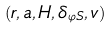<formula> <loc_0><loc_0><loc_500><loc_500>( r , a , H , \delta _ { \varphi S } , v )</formula> 